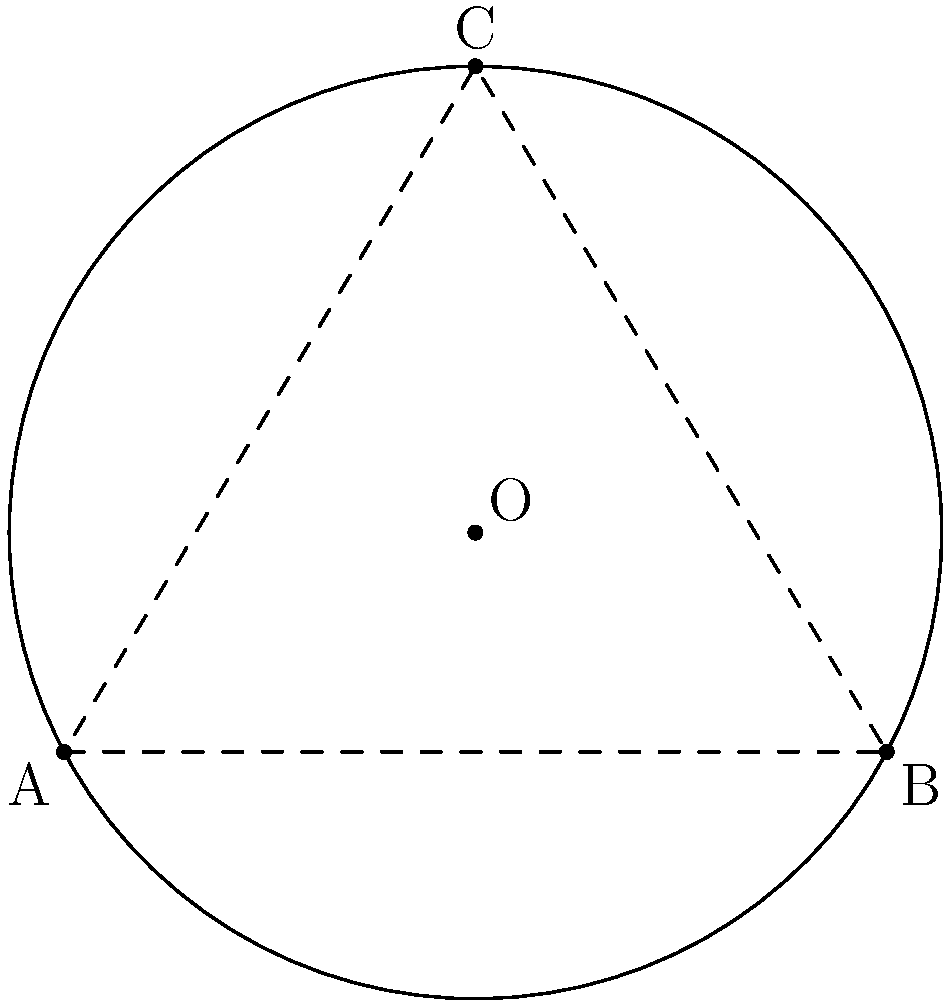In your latest art detective adventure, you've been tasked with finding the center of a circular exhibit hall. You've cleverly deduced three points on the perimeter: A(0,0), B(6,0), and C(3,5). Using your knowledge of coordinate geometry, determine the coordinates of the center point O. Round your answer to two decimal places. To find the center of a circle given three points on its circumference, we can use the following steps:

1) The center of the circle is the point where the perpendicular bisectors of any two chords intersect.

2) Let's choose AB and BC as our chords.

3) For AB:
   Midpoint: $(\frac{0+6}{2}, \frac{0+0}{2}) = (3,0)$
   Slope of AB: $m_{AB} = \frac{0-0}{6-0} = 0$
   Perpendicular slope: $m_{\perp AB} = -\frac{1}{m_{AB}} = \text{undefined}$ (vertical line)
   Equation of perpendicular bisector of AB: $x = 3$

4) For BC:
   Midpoint: $(\frac{6+3}{2}, \frac{0+5}{2}) = (4.5, 2.5)$
   Slope of BC: $m_{BC} = \frac{5-0}{3-6} = -\frac{5}{3}$
   Perpendicular slope: $m_{\perp BC} = \frac{3}{5}$
   Equation of perpendicular bisector of BC: $y - 2.5 = \frac{3}{5}(x - 4.5)$

5) The center is where these lines intersect:
   $x = 3$
   $y - 2.5 = \frac{3}{5}(3 - 4.5) = -0.9$
   $y = 1.6$

Therefore, the center O has coordinates (3, 1.6).
Answer: (3.00, 1.60) 